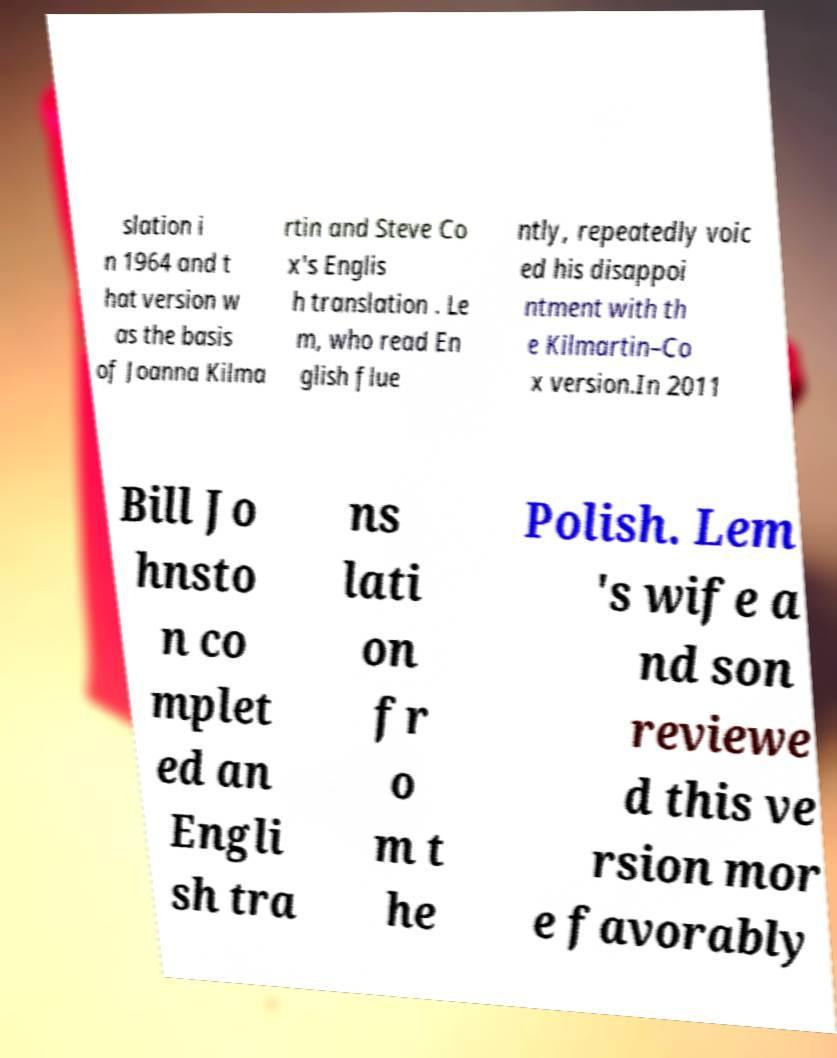What messages or text are displayed in this image? I need them in a readable, typed format. slation i n 1964 and t hat version w as the basis of Joanna Kilma rtin and Steve Co x's Englis h translation . Le m, who read En glish flue ntly, repeatedly voic ed his disappoi ntment with th e Kilmartin–Co x version.In 2011 Bill Jo hnsto n co mplet ed an Engli sh tra ns lati on fr o m t he Polish. Lem 's wife a nd son reviewe d this ve rsion mor e favorably 